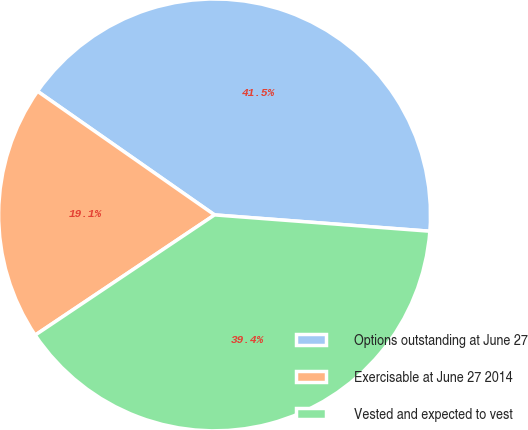Convert chart to OTSL. <chart><loc_0><loc_0><loc_500><loc_500><pie_chart><fcel>Options outstanding at June 27<fcel>Exercisable at June 27 2014<fcel>Vested and expected to vest<nl><fcel>41.5%<fcel>19.1%<fcel>39.4%<nl></chart> 